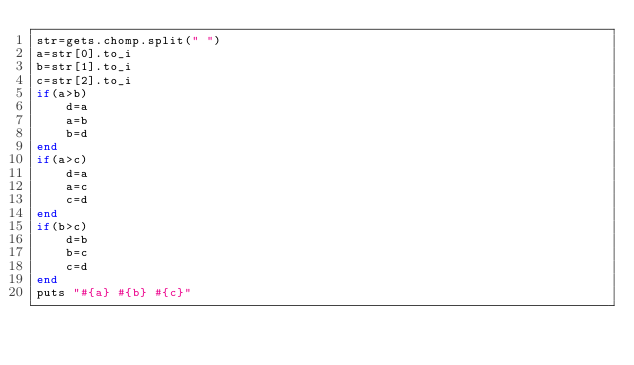Convert code to text. <code><loc_0><loc_0><loc_500><loc_500><_Ruby_>str=gets.chomp.split(" ")
a=str[0].to_i
b=str[1].to_i
c=str[2].to_i
if(a>b)
	d=a
	a=b
	b=d
end
if(a>c)
	d=a
	a=c
	c=d
end
if(b>c)
	d=b
	b=c
	c=d
end
puts "#{a} #{b} #{c}"</code> 